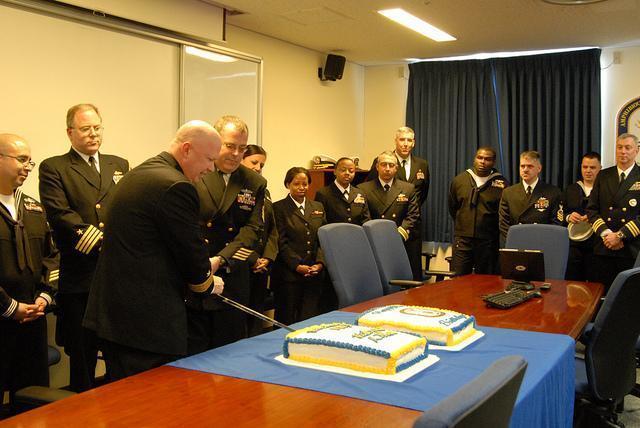How many cakes are on the table?
Give a very brief answer. 2. How many chairs can be seen?
Give a very brief answer. 5. How many people are in the picture?
Give a very brief answer. 10. How many cakes are in the picture?
Give a very brief answer. 2. How many buses are red and white striped?
Give a very brief answer. 0. 